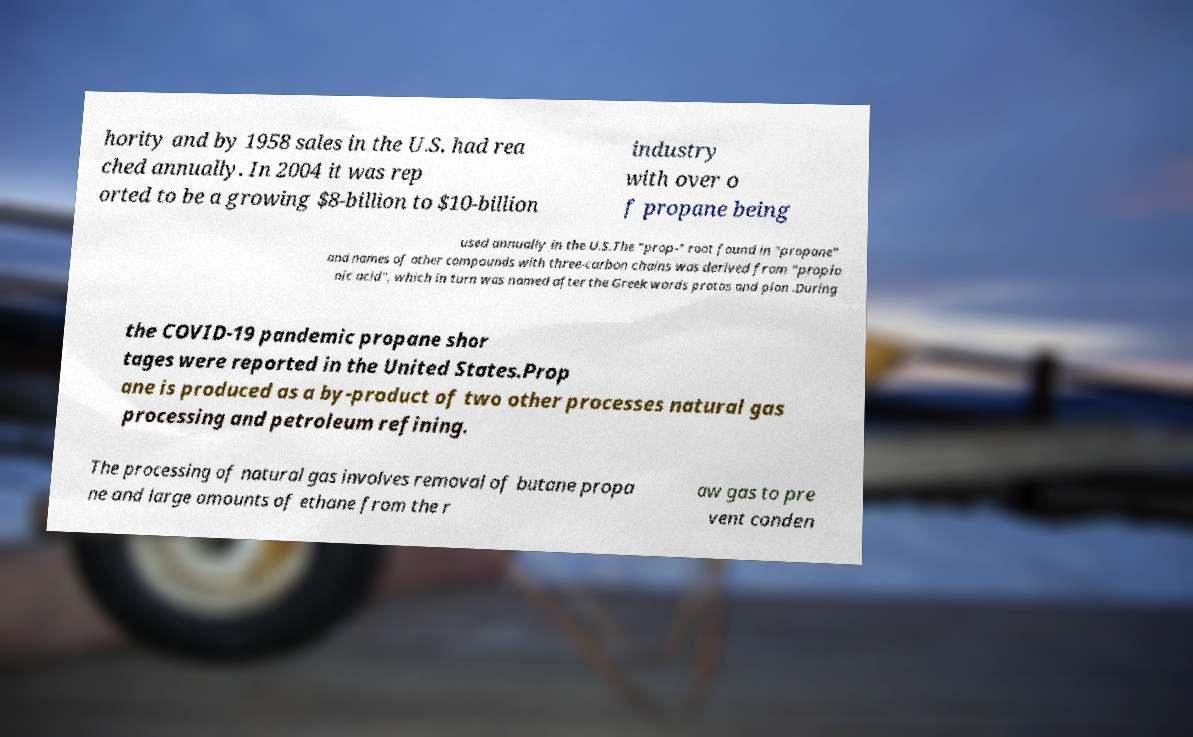I need the written content from this picture converted into text. Can you do that? hority and by 1958 sales in the U.S. had rea ched annually. In 2004 it was rep orted to be a growing $8-billion to $10-billion industry with over o f propane being used annually in the U.S.The "prop-" root found in "propane" and names of other compounds with three-carbon chains was derived from "propio nic acid", which in turn was named after the Greek words protos and pion .During the COVID-19 pandemic propane shor tages were reported in the United States.Prop ane is produced as a by-product of two other processes natural gas processing and petroleum refining. The processing of natural gas involves removal of butane propa ne and large amounts of ethane from the r aw gas to pre vent conden 